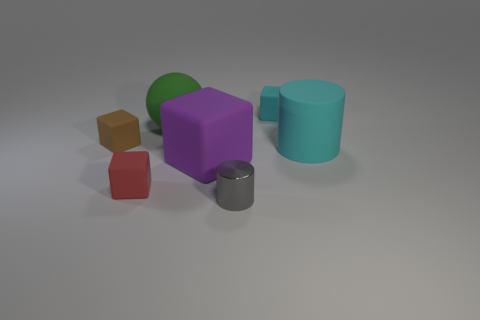Add 3 small shiny cylinders. How many objects exist? 10 Subtract all cylinders. How many objects are left? 5 Add 3 green rubber things. How many green rubber things exist? 4 Subtract 1 brown cubes. How many objects are left? 6 Subtract all blue matte cylinders. Subtract all small cyan things. How many objects are left? 6 Add 2 small rubber things. How many small rubber things are left? 5 